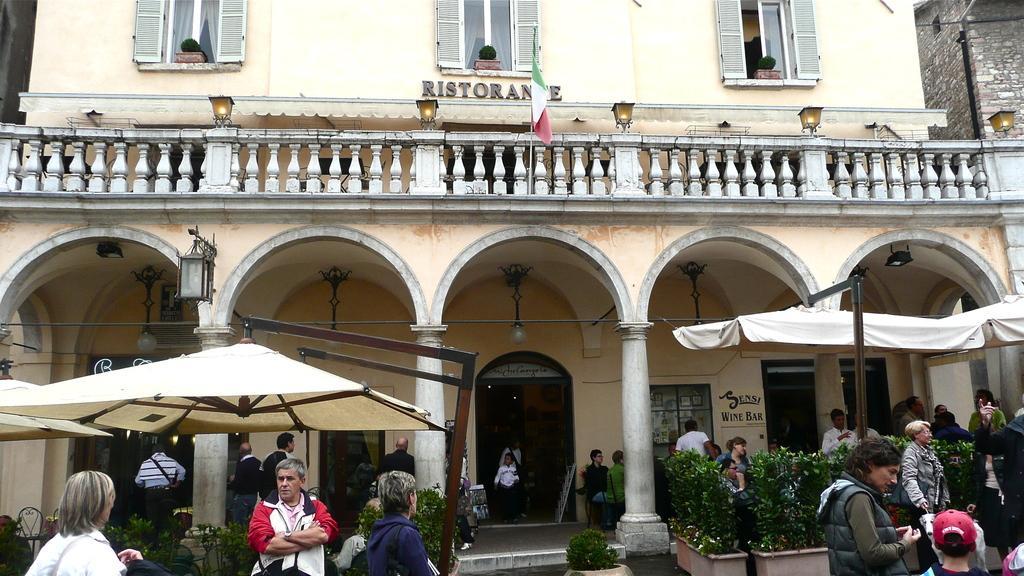Please provide a concise description of this image. In this image, we can see a building and there are windows and lights and we can see a flag. At the bottom, there are some people and we can see flower pots, tents, poles, rods, chairs and boards. 